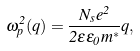Convert formula to latex. <formula><loc_0><loc_0><loc_500><loc_500>\omega ^ { 2 } _ { p } ( q ) = \frac { N _ { s } e ^ { 2 } } { 2 \varepsilon \varepsilon _ { 0 } m ^ { \ast } } q ,</formula> 